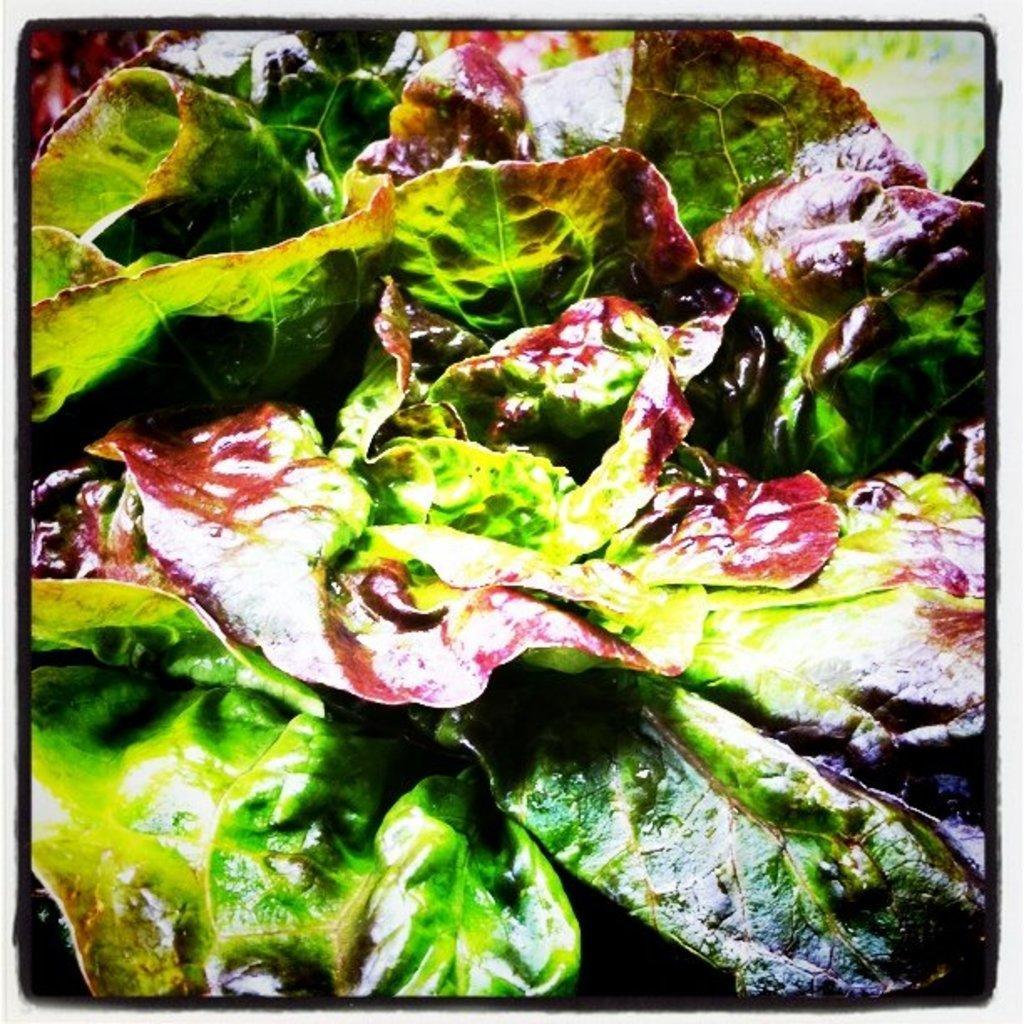Please provide a concise description of this image. In this picture we can see a few leaves throughout the image. 